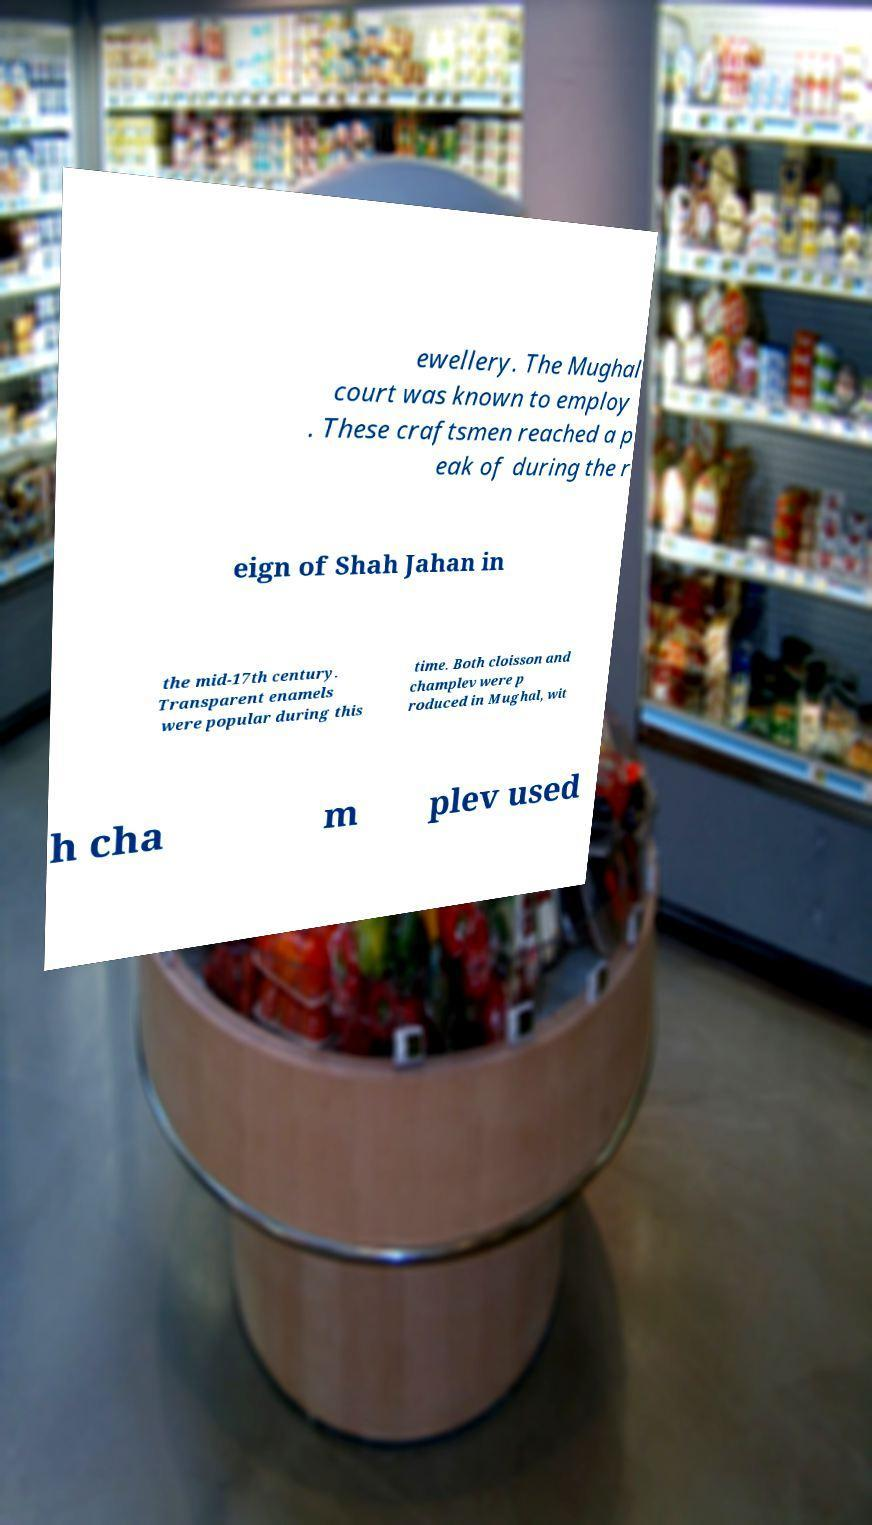Can you read and provide the text displayed in the image?This photo seems to have some interesting text. Can you extract and type it out for me? ewellery. The Mughal court was known to employ . These craftsmen reached a p eak of during the r eign of Shah Jahan in the mid-17th century. Transparent enamels were popular during this time. Both cloisson and champlev were p roduced in Mughal, wit h cha m plev used 